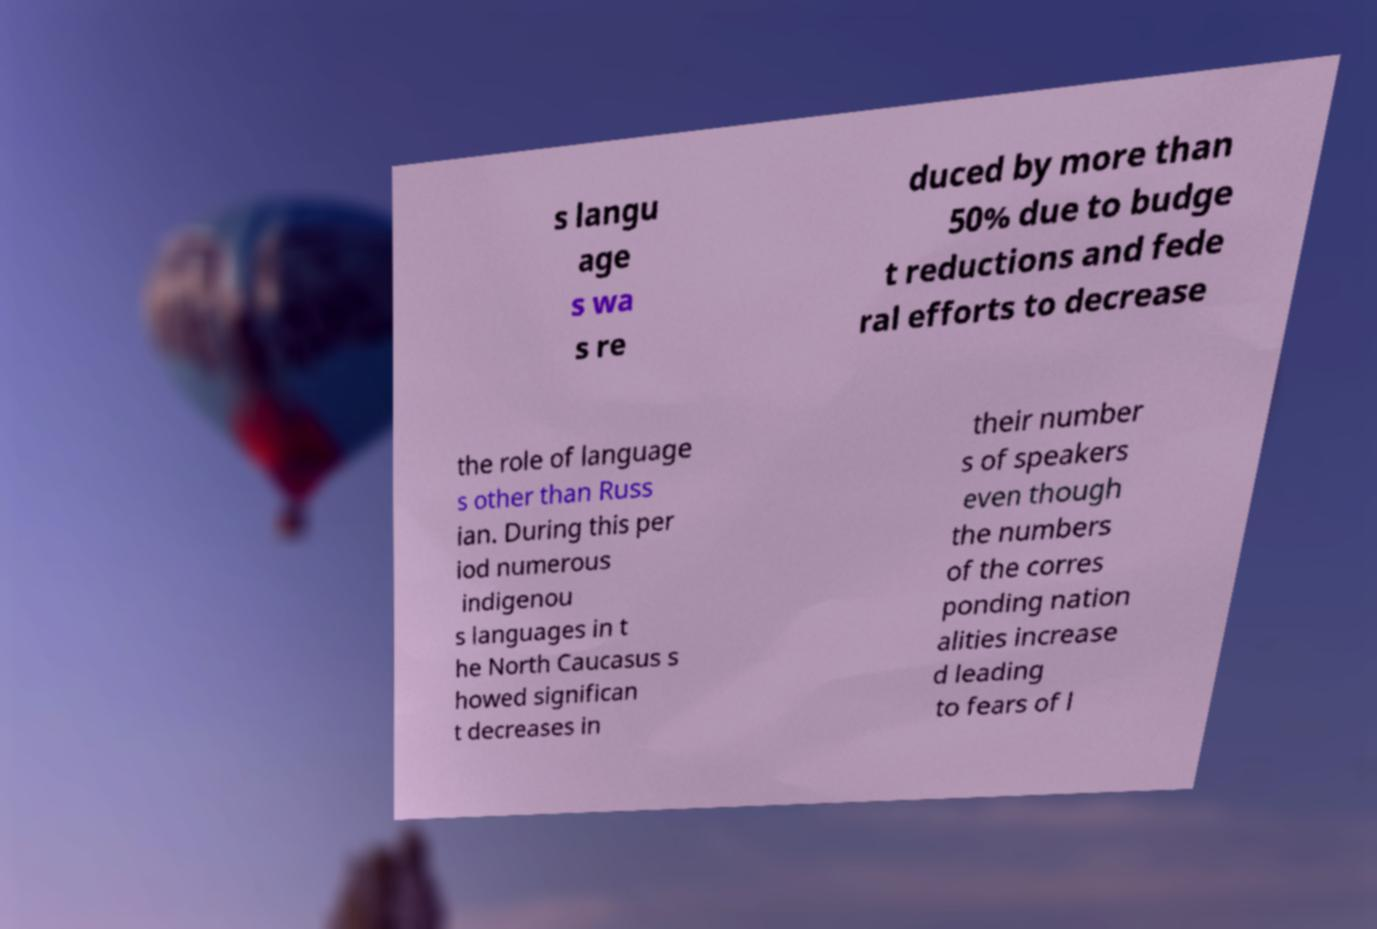Can you read and provide the text displayed in the image?This photo seems to have some interesting text. Can you extract and type it out for me? s langu age s wa s re duced by more than 50% due to budge t reductions and fede ral efforts to decrease the role of language s other than Russ ian. During this per iod numerous indigenou s languages in t he North Caucasus s howed significan t decreases in their number s of speakers even though the numbers of the corres ponding nation alities increase d leading to fears of l 